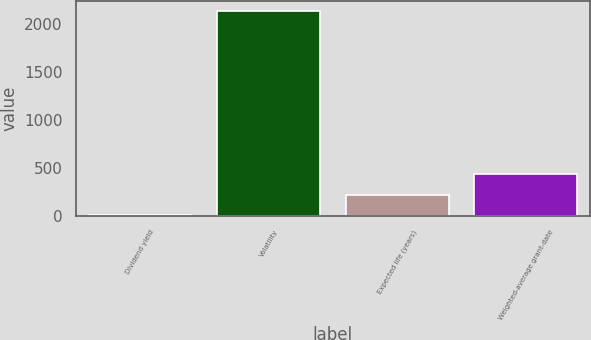Convert chart. <chart><loc_0><loc_0><loc_500><loc_500><bar_chart><fcel>Dividend yield<fcel>Volatility<fcel>Expected life (years)<fcel>Weighted-average grant-date<nl><fcel>1.4<fcel>2139<fcel>215.16<fcel>428.92<nl></chart> 